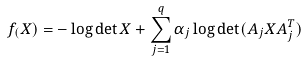Convert formula to latex. <formula><loc_0><loc_0><loc_500><loc_500>f _ { ( } X ) = - \log \det X + \sum _ { j = 1 } ^ { q } \alpha _ { j } \log \det ( A _ { j } X A _ { j } ^ { T } )</formula> 